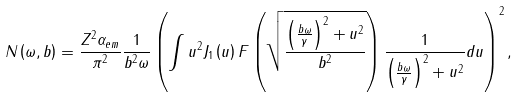<formula> <loc_0><loc_0><loc_500><loc_500>N \left ( \omega , b \right ) = \frac { Z ^ { 2 } \alpha _ { e m } } { \pi ^ { 2 } } \frac { 1 } { b ^ { 2 } \omega } \left ( \int u ^ { 2 } J _ { 1 } \left ( u \right ) F \left ( \sqrt { \frac { \left ( \frac { b \omega } { \gamma } \right ) ^ { 2 } + u ^ { 2 } } { b ^ { 2 } } } \right ) \frac { 1 } { \left ( \frac { b \omega } { \gamma } \right ) ^ { 2 } + u ^ { 2 } } d u \right ) ^ { 2 } ,</formula> 